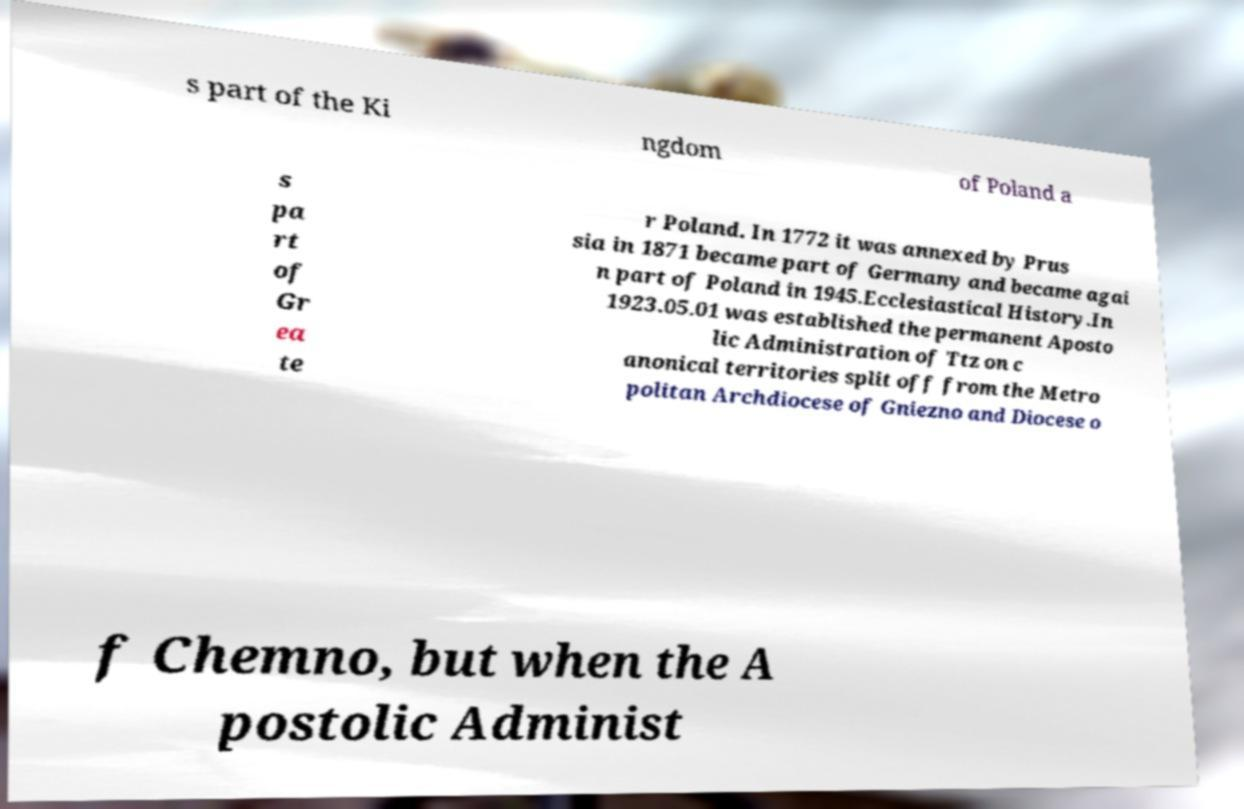There's text embedded in this image that I need extracted. Can you transcribe it verbatim? s part of the Ki ngdom of Poland a s pa rt of Gr ea te r Poland. In 1772 it was annexed by Prus sia in 1871 became part of Germany and became agai n part of Poland in 1945.Ecclesiastical History.In 1923.05.01 was established the permanent Aposto lic Administration of Ttz on c anonical territories split off from the Metro politan Archdiocese of Gniezno and Diocese o f Chemno, but when the A postolic Administ 